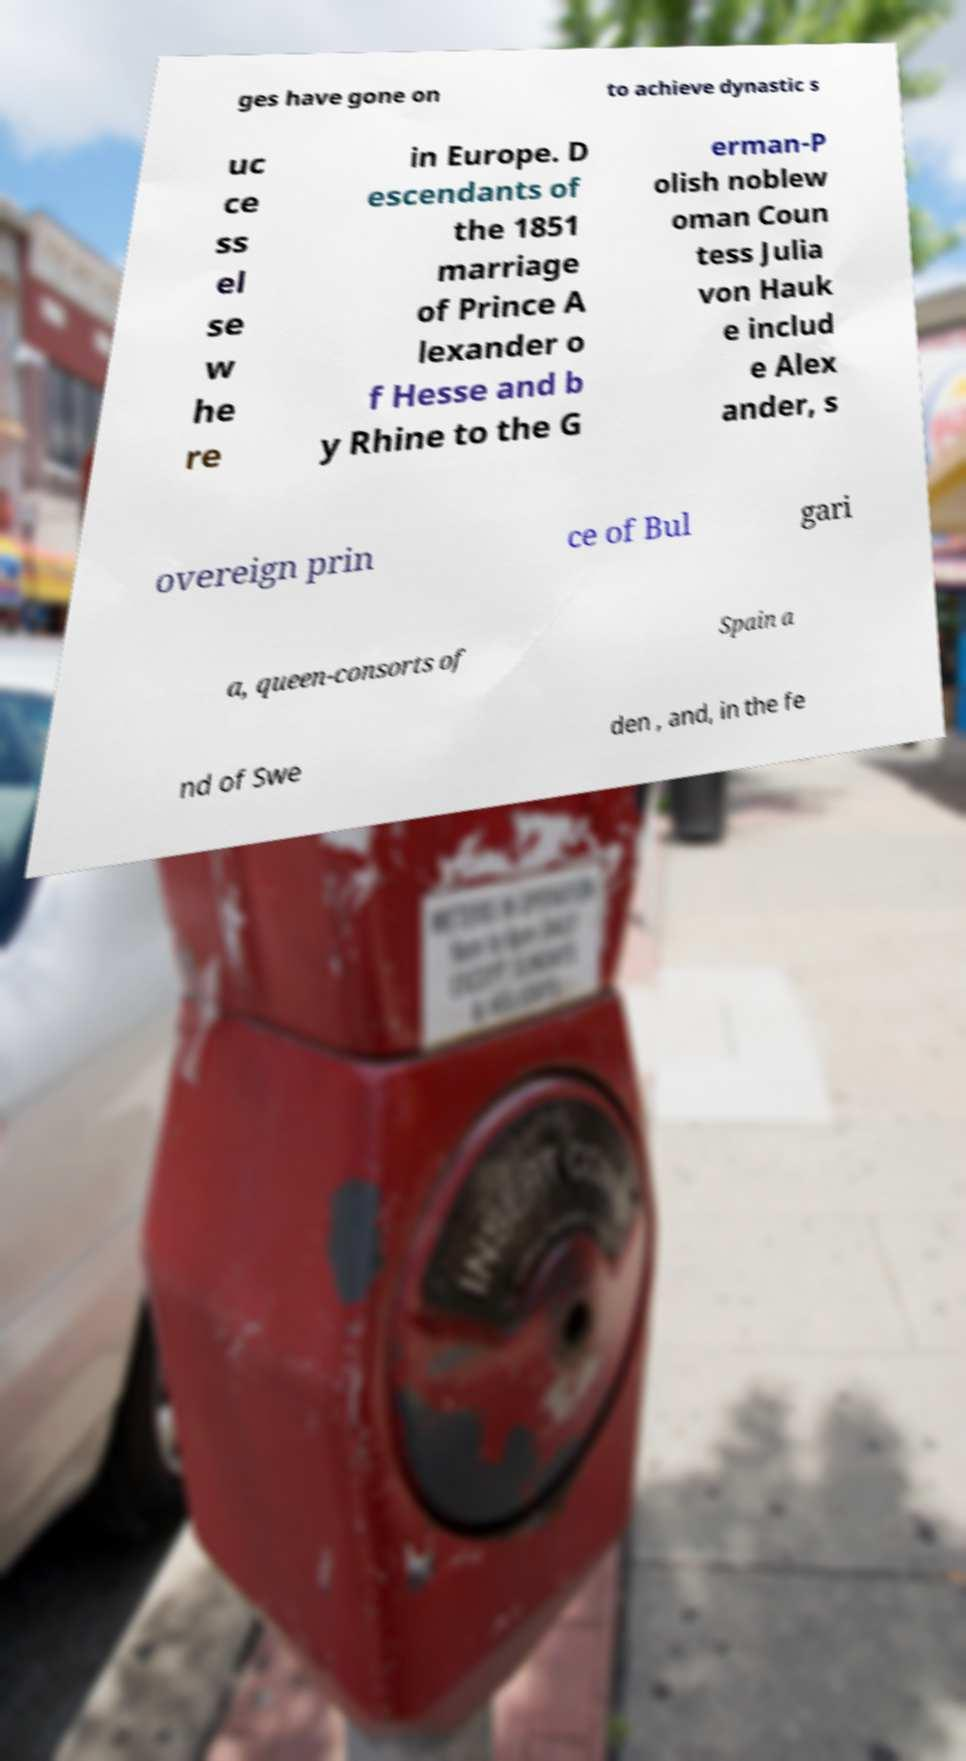Can you read and provide the text displayed in the image?This photo seems to have some interesting text. Can you extract and type it out for me? ges have gone on to achieve dynastic s uc ce ss el se w he re in Europe. D escendants of the 1851 marriage of Prince A lexander o f Hesse and b y Rhine to the G erman-P olish noblew oman Coun tess Julia von Hauk e includ e Alex ander, s overeign prin ce of Bul gari a, queen-consorts of Spain a nd of Swe den , and, in the fe 